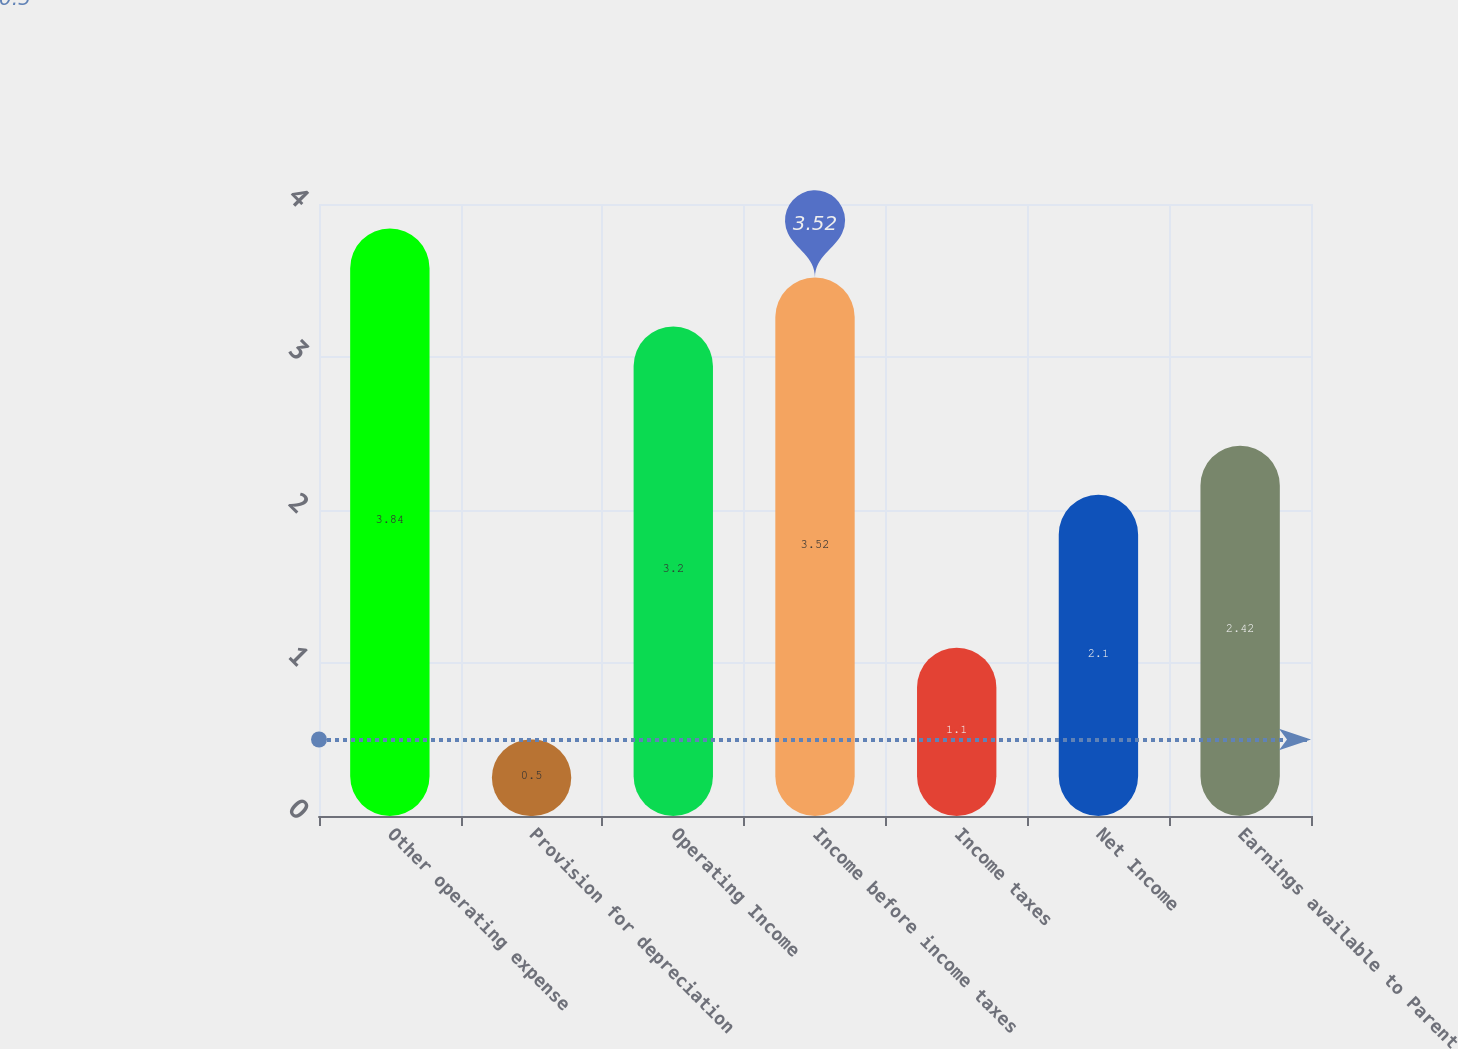Convert chart. <chart><loc_0><loc_0><loc_500><loc_500><bar_chart><fcel>Other operating expense<fcel>Provision for depreciation<fcel>Operating Income<fcel>Income before income taxes<fcel>Income taxes<fcel>Net Income<fcel>Earnings available to Parent<nl><fcel>3.84<fcel>0.5<fcel>3.2<fcel>3.52<fcel>1.1<fcel>2.1<fcel>2.42<nl></chart> 